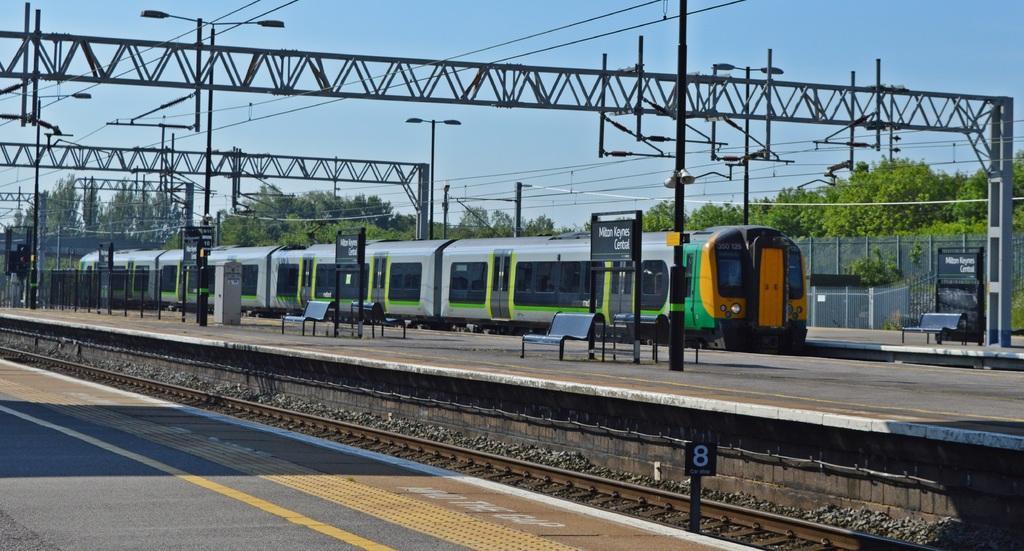Could you give a brief overview of what you see in this image? In the image there is a train in the back side with platform on either side of it and above there is metal arch and in the background there are trees and above its sky. 